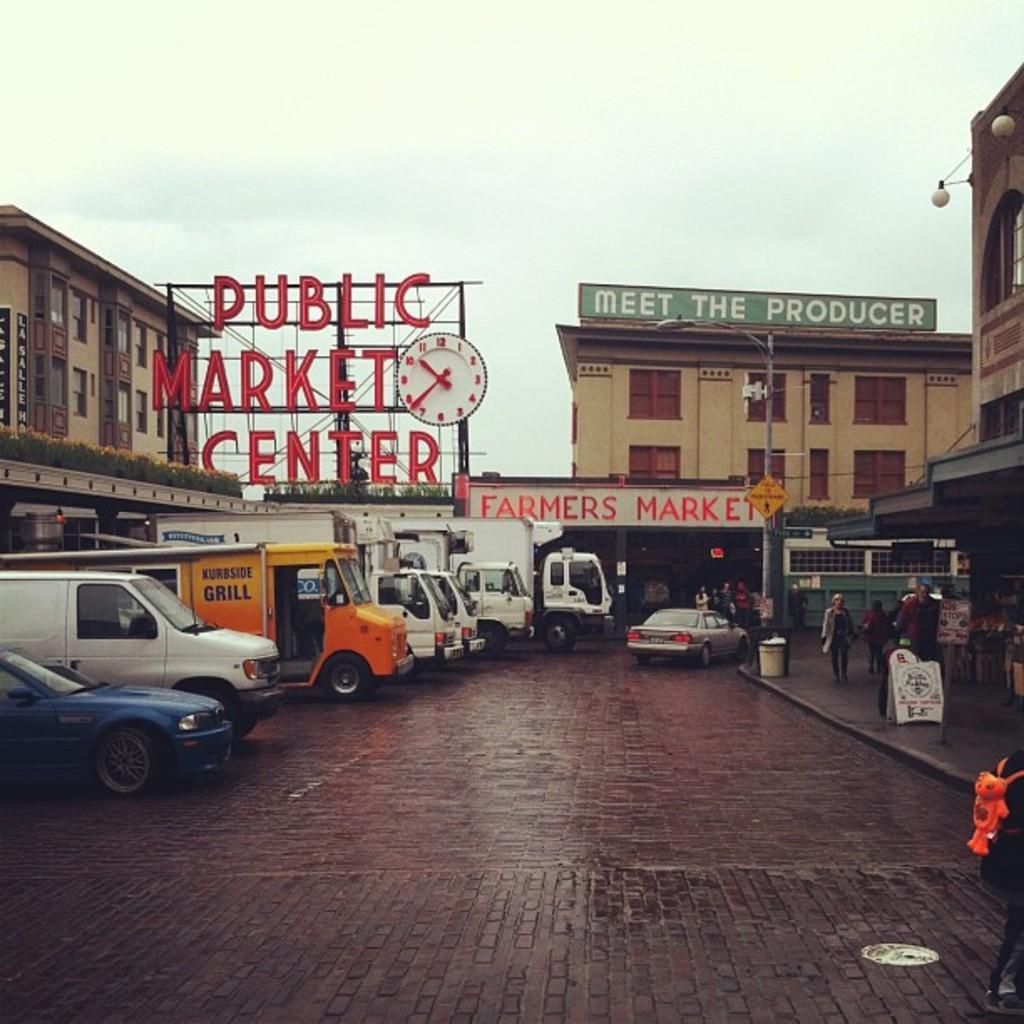How would you summarize this image in a sentence or two? In the image we can see these vehicles are parked on the road. Here we can see these people walking on the sidewalk, we can see boards, light poles, we can see hoarding with some text on it and we can see a clock, we can see buildings and the sky in the background. 